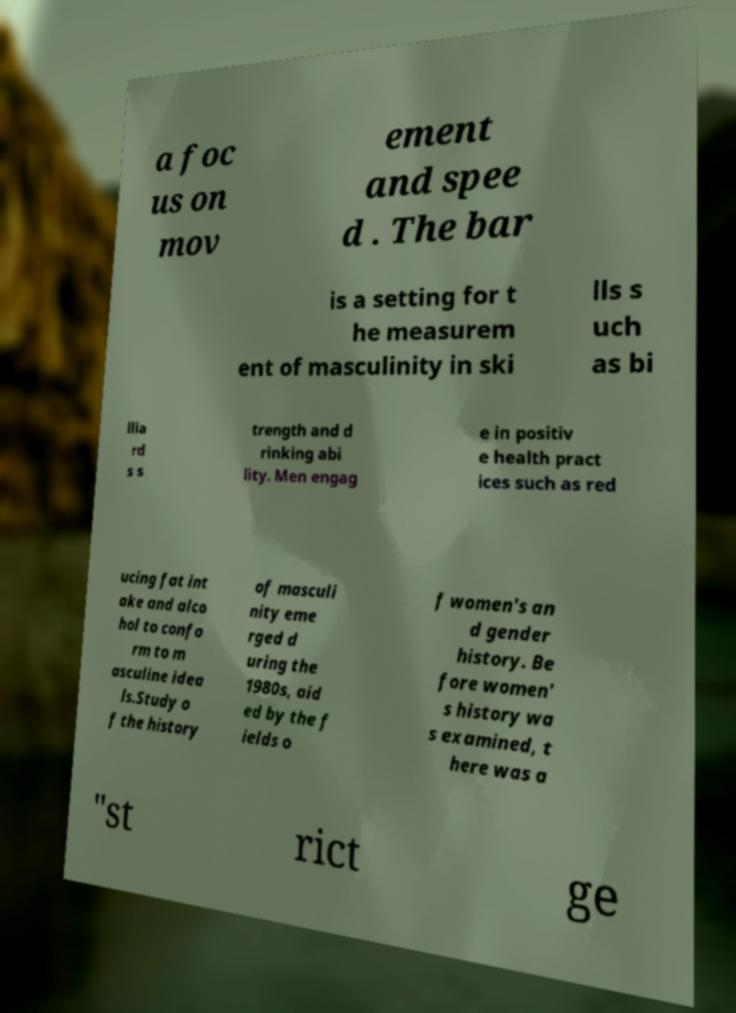Please read and relay the text visible in this image. What does it say? a foc us on mov ement and spee d . The bar is a setting for t he measurem ent of masculinity in ski lls s uch as bi llia rd s s trength and d rinking abi lity. Men engag e in positiv e health pract ices such as red ucing fat int ake and alco hol to confo rm to m asculine idea ls.Study o f the history of masculi nity eme rged d uring the 1980s, aid ed by the f ields o f women's an d gender history. Be fore women' s history wa s examined, t here was a "st rict ge 